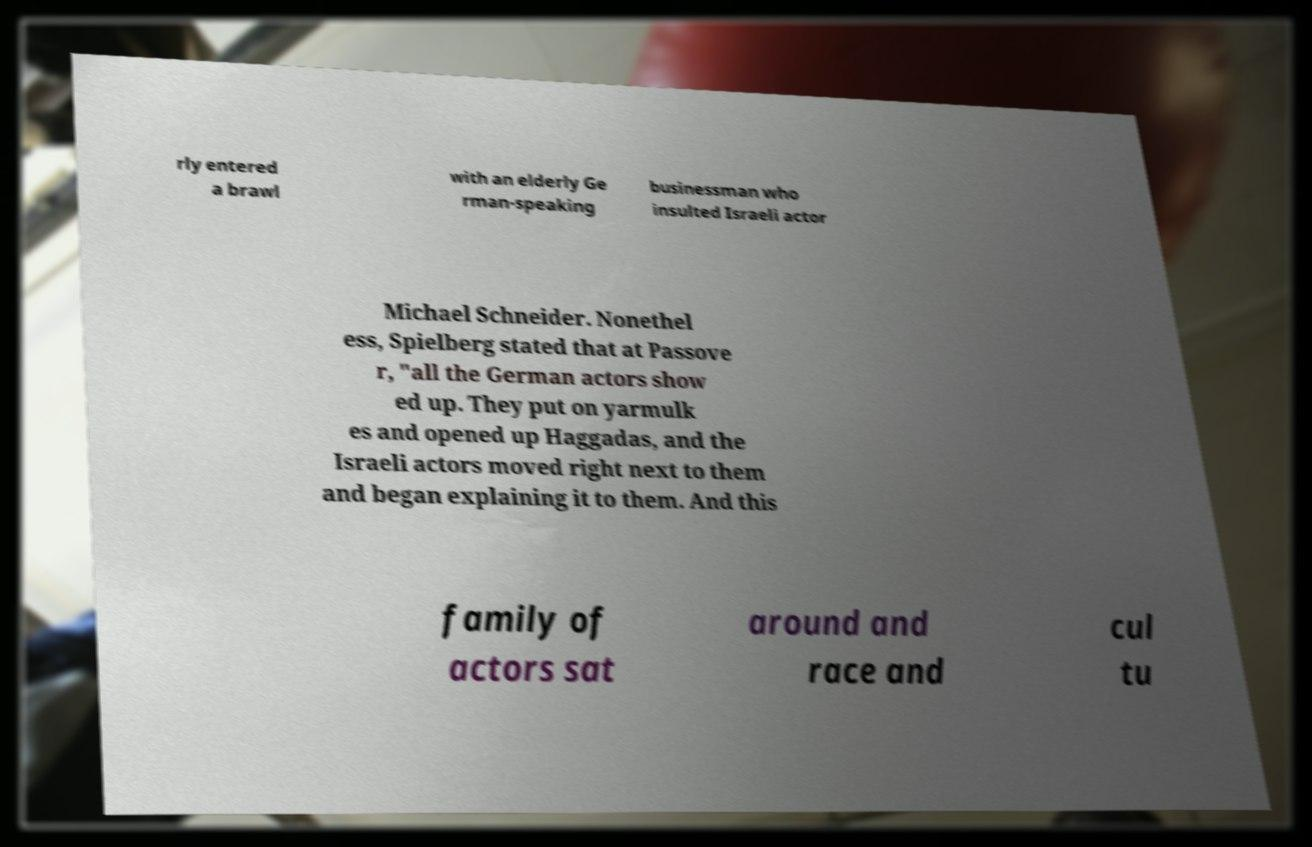For documentation purposes, I need the text within this image transcribed. Could you provide that? rly entered a brawl with an elderly Ge rman-speaking businessman who insulted Israeli actor Michael Schneider. Nonethel ess, Spielberg stated that at Passove r, "all the German actors show ed up. They put on yarmulk es and opened up Haggadas, and the Israeli actors moved right next to them and began explaining it to them. And this family of actors sat around and race and cul tu 